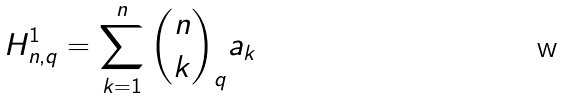<formula> <loc_0><loc_0><loc_500><loc_500>H _ { n , q } ^ { 1 } = \sum _ { k = 1 } ^ { n } \binom { n } { k } _ { q } a _ { k }</formula> 